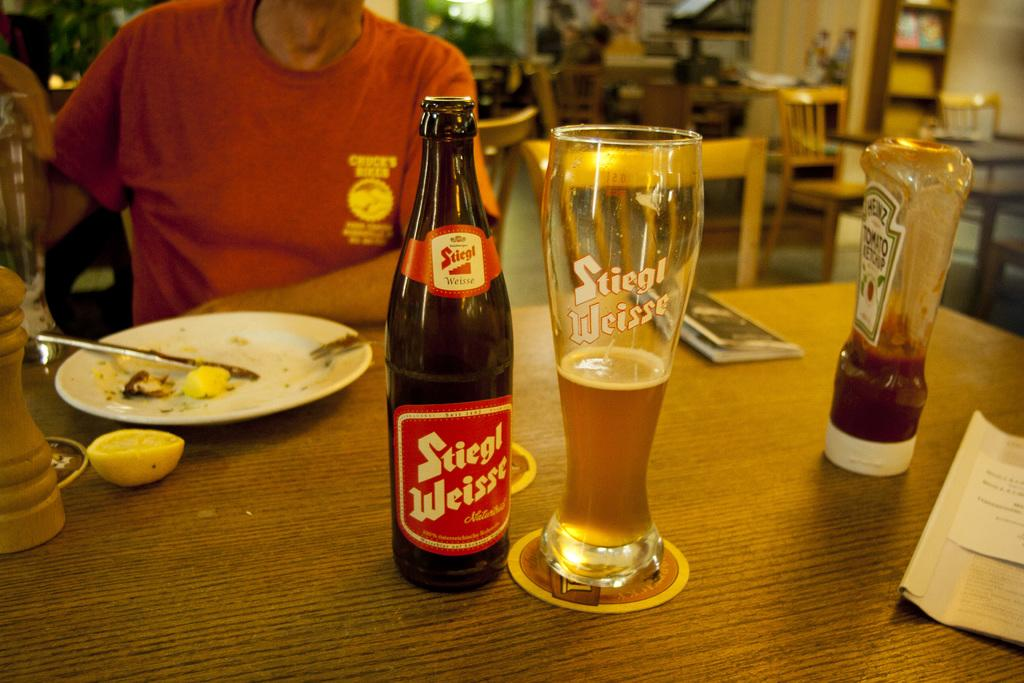<image>
Relay a brief, clear account of the picture shown. the word Stiegl Weisse that is on a bottle 